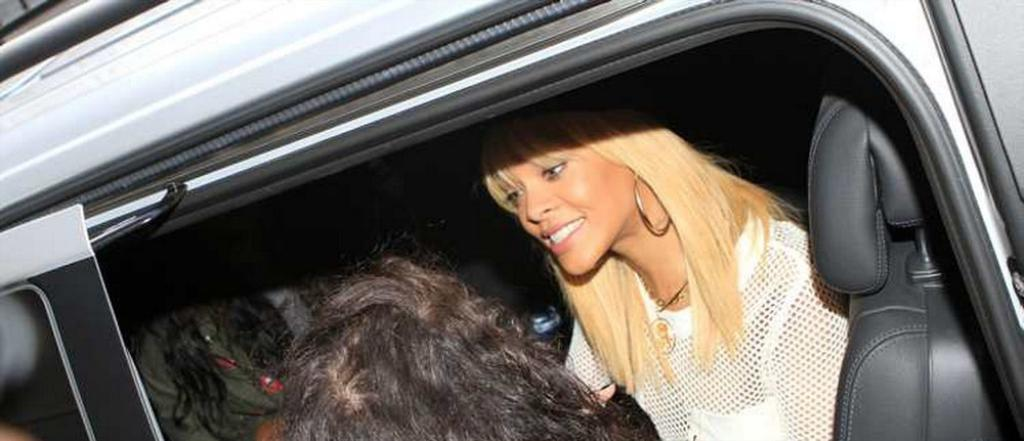Who is present in the image? There is a woman in the image. What is the setting of the image? The woman is inside a car. Are there any other people in the image? Yes, there are two other people in the image. How are the two other people positioned in relation to the woman? The two other people are beside the woman. What type of animal can be seen sitting on the woman's lap in the image? There is no animal present in the image; it only features the woman and two other people. What chalk drawings can be seen on the car's windows in the image? There are no chalk drawings visible on the car's windows in the image. What type of stamp is visible on the woman's forehead in the image? There is no stamp visible on the woman's forehead in the image. 